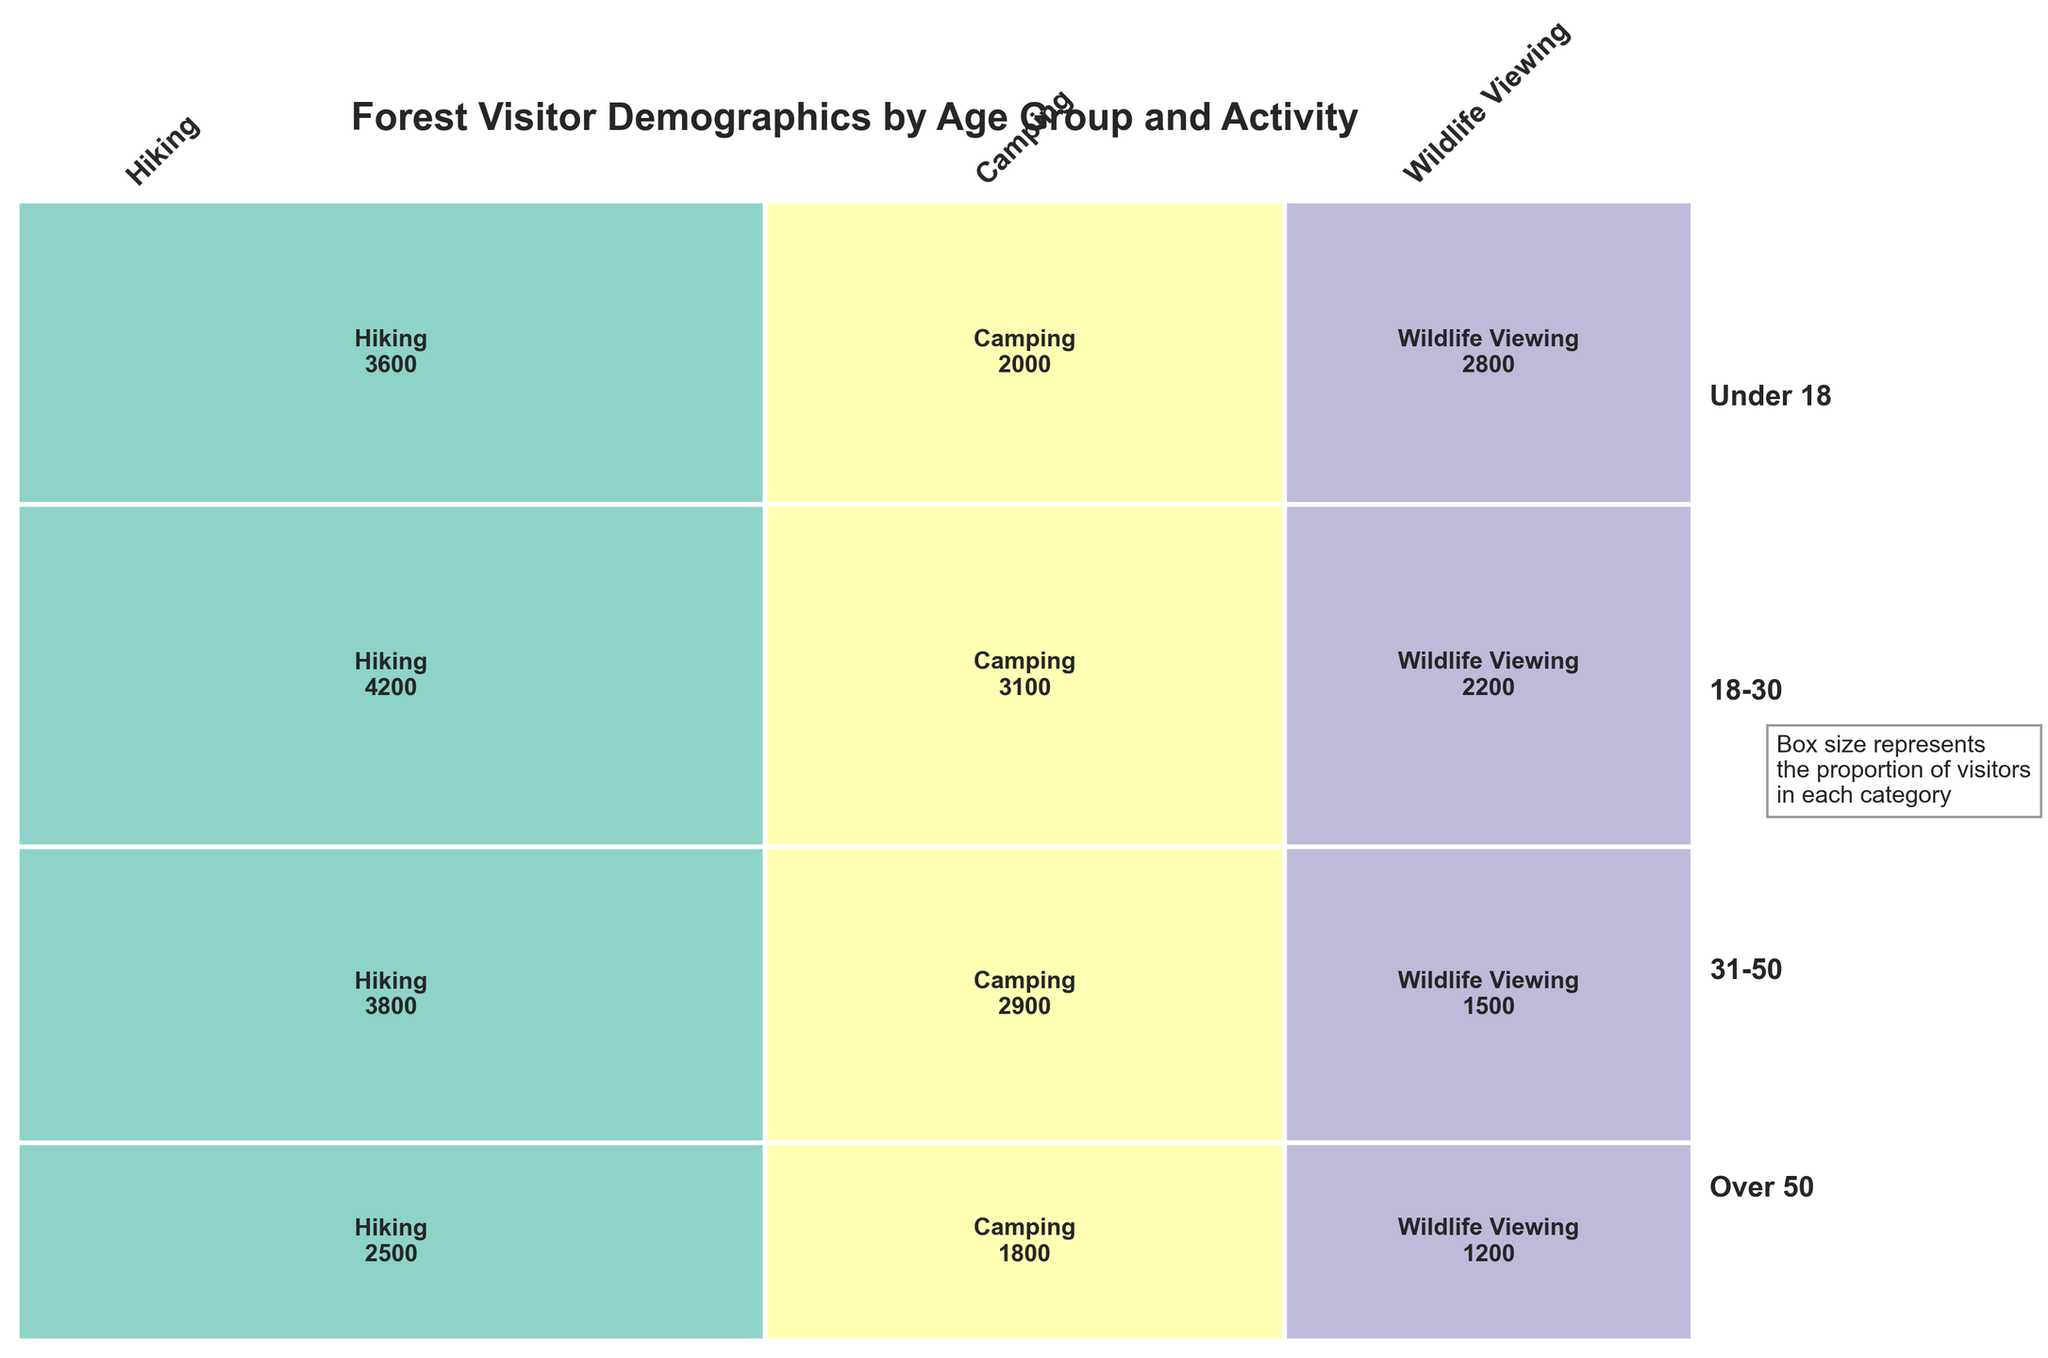What is the title of the mosaic plot? Look at the top of the plot to see the text set as the title.
Answer: Forest Visitor Demographics by Age Group and Activity Which age group has the smallest proportion of visitors? Observe the vertical sections representing each age group from bottom to top. Identify the section with the smallest height.
Answer: Under 18 How many visitors aged 18-30 engage in camping? Find the section for ages 18-30 and within it, locate the portion for camping. Read the number present in that section.
Answer: 2900 Which activity has the largest total number of visitors? Compare the widths of the sections for Hiking, Camping, and Wildlife Viewing across all age groups. The widest section represents the most popular activity.
Answer: Hiking Is the proportion of visitors in the age group 31-50 greater than those over 50 who participate in hiking? Compare the heights of the sections for 31-50 and Over 50 in the hiking activity category.
Answer: Yes What is the total number of visitors participating in wildlife viewing? Add the number of visitors for wildlife viewing across all age groups: 1200 (Under 18) + 1500 (18-30) + 2200 (31-50) + 2800 (Over 50).
Answer: 7700 Which age group has the largest proportion of visitors participating in camping? Look at the vertical sections corresponding to each age group and within each, find the portion for camping. Identify the largest.
Answer: 31-50 Compare the number of visitors under 18 participating in hiking with those over 50 participating in wildlife viewing. Which group has more visitors? Find and compare the numbers in the respective sections: 2500 for hiking under 18 and 2800 for wildlife viewing over 50.
Answer: Over 50 in wildlife viewing How many more visitors from the age group 31-50 engage in hiking compared to camping? Subtract the number of camping visitors (3100) from hiking visitors (4200) within the age group 31-50: 4200 - 3100.
Answer: 1100 What is the combined proportion of visitors for the age groups Under 18 and Over 50? Sum the proportions of the sections for Under 18 and Over 50. These values can be found visually by comparing heights to the total.
Answer: 0.48 